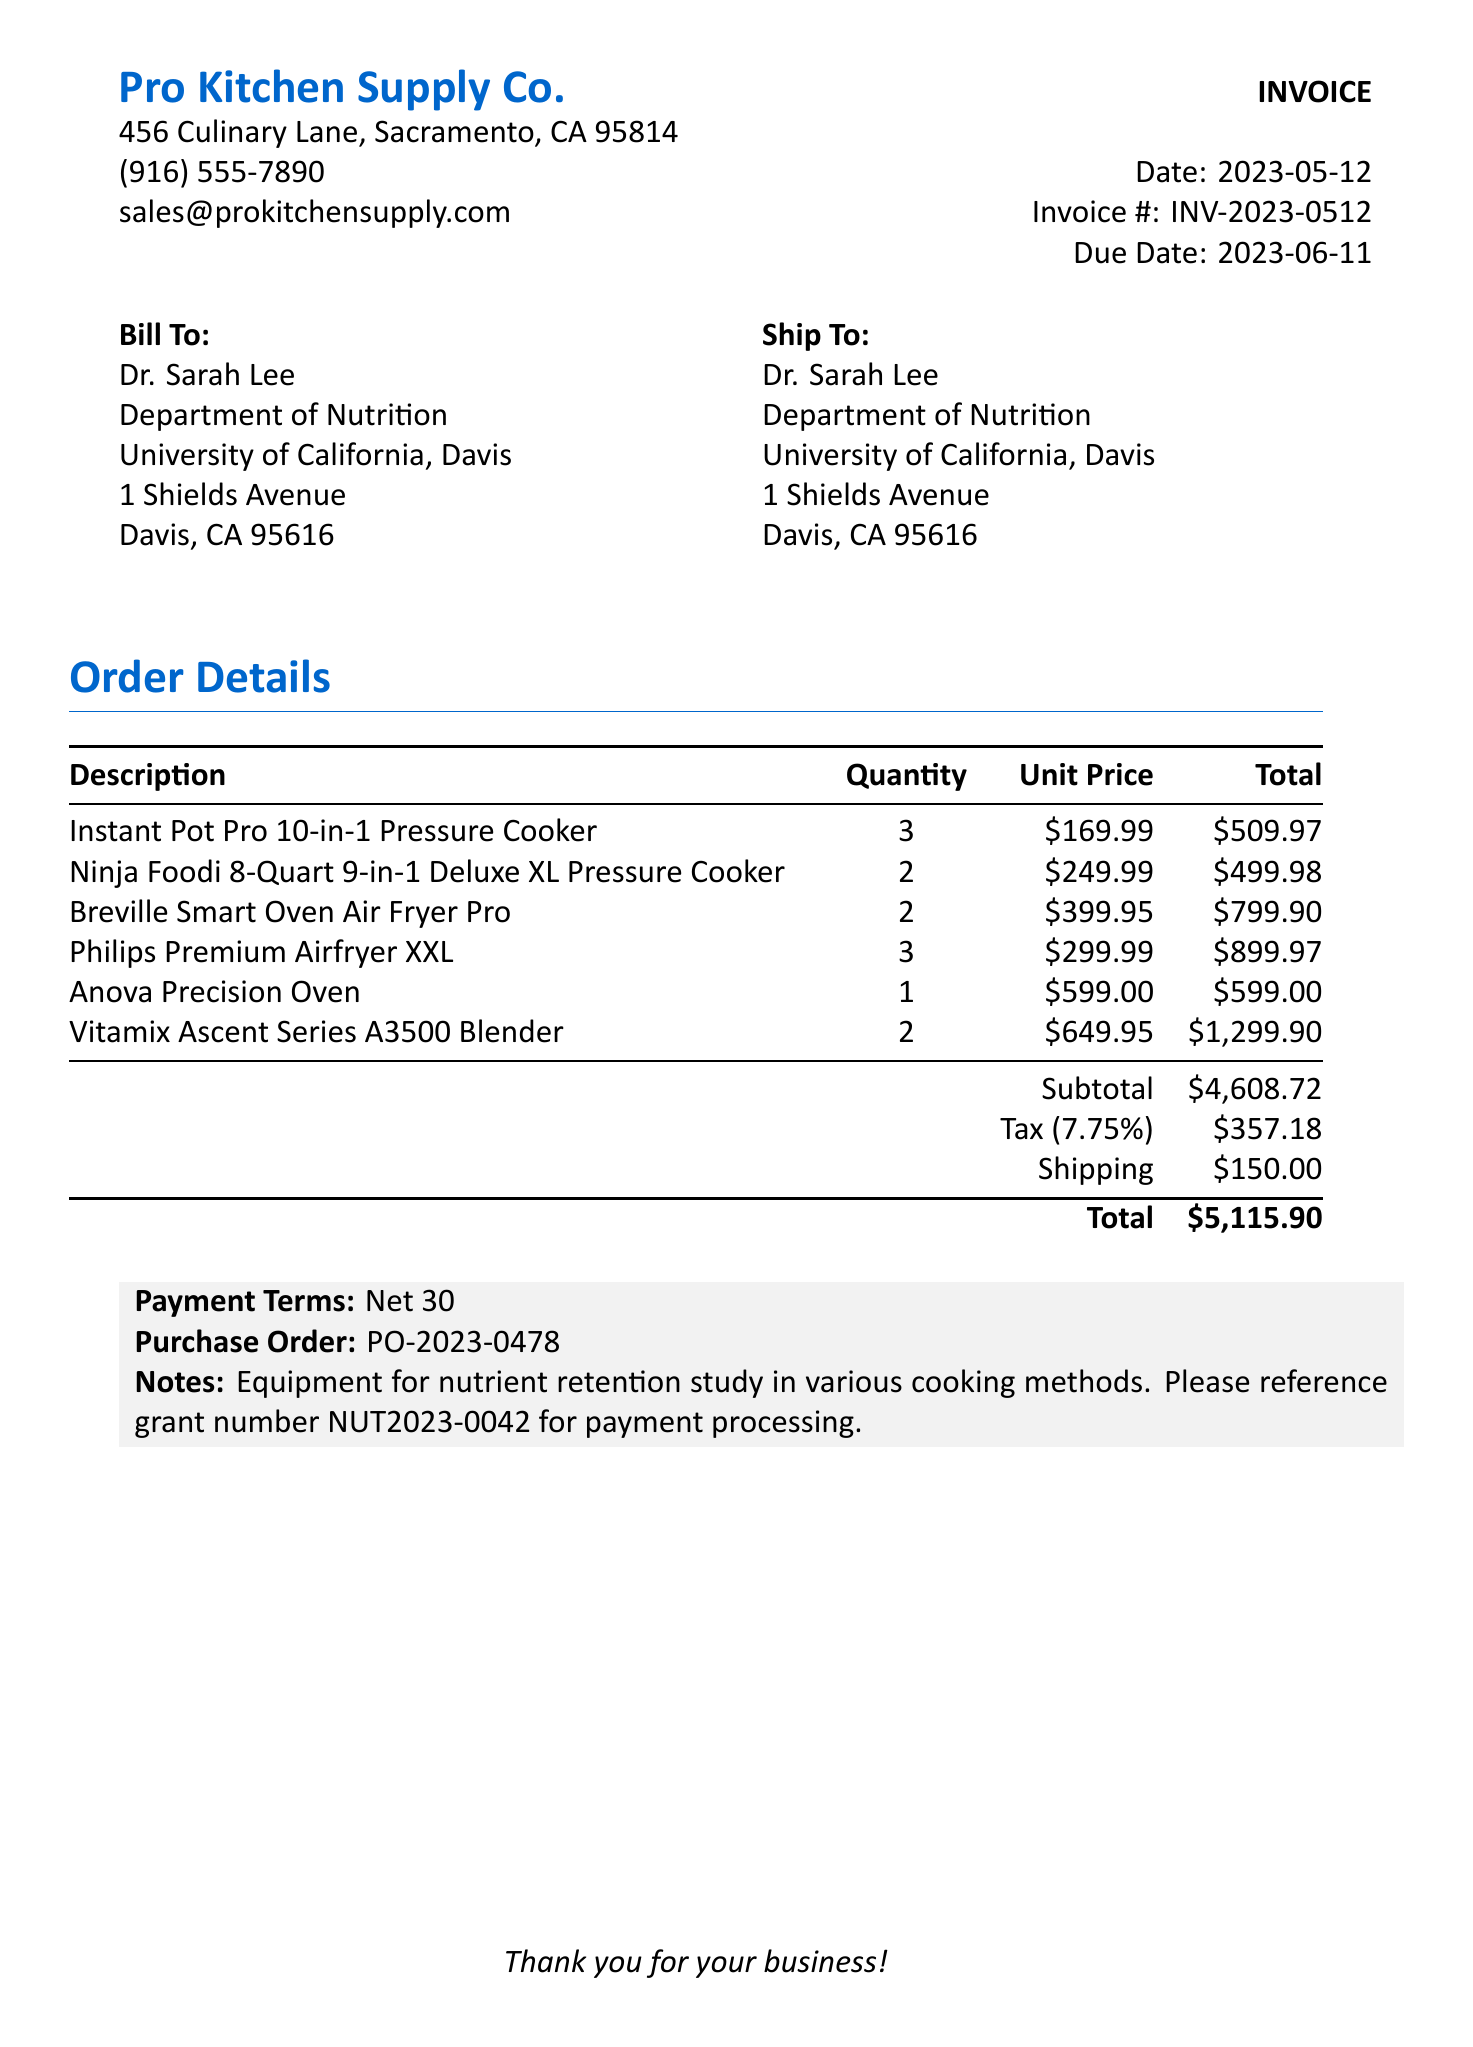What is the invoice number? The invoice number can be found at the top of the invoice, clearly labeled.
Answer: INV-2023-0512 What is the total amount due? The total amount due is located at the bottom section of the document under the total.
Answer: $5,115.90 Who is the researcher? The researcher’s name is specified in the bill to section of the invoice.
Answer: Dr. Sarah Lee What is the tax rate applied? The tax rate is mentioned above the tax amount in the order details section.
Answer: 7.75% How many Ninja Foodi pressure cookers were purchased? The quantity for the Ninja Foodi pressure cookers is listed in the order details table.
Answer: 2 What is the subtotal before tax and shipping? The subtotal is presented in the order details, prior to the tax and shipping charges.
Answer: $4,608.72 What is the payment term stated in the invoice? The payment term can be found in the payment terms section of the document.
Answer: Net 30 What is the shipping cost? The shipping cost is detailed in the order totals section.
Answer: $150.00 What is the grant number referenced for payment processing? The grant number is mentioned in the notes at the bottom of the invoice.
Answer: NUT2023-0042 